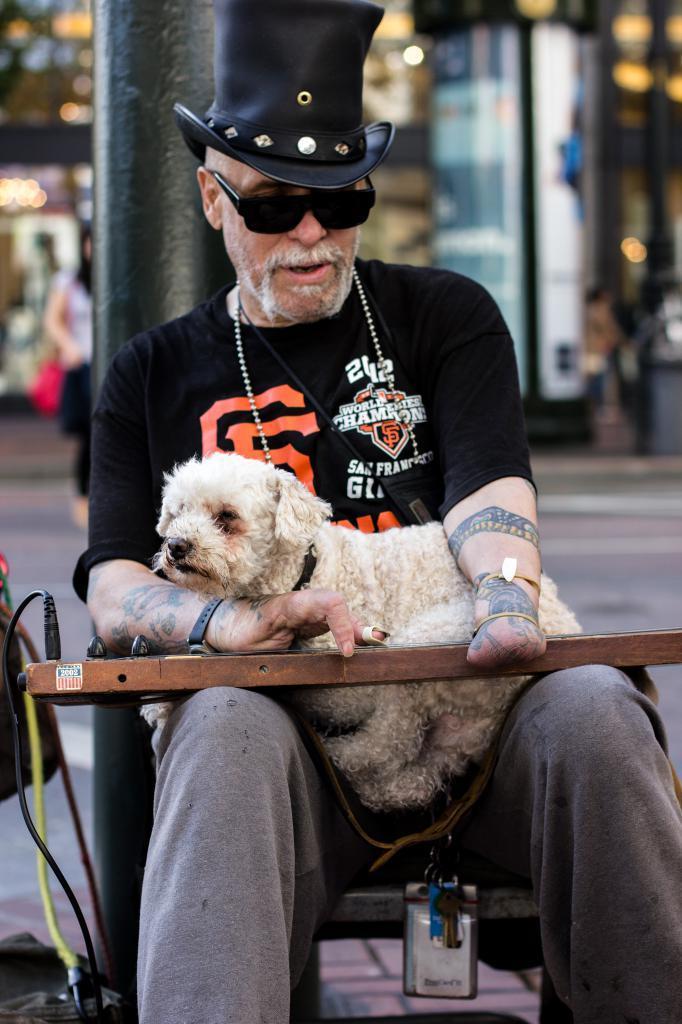Describe this image in one or two sentences. In this image there is one person who is sitting on a chair and he is holding a puppy and he is wearing a black hat, beside him there is one pole. 